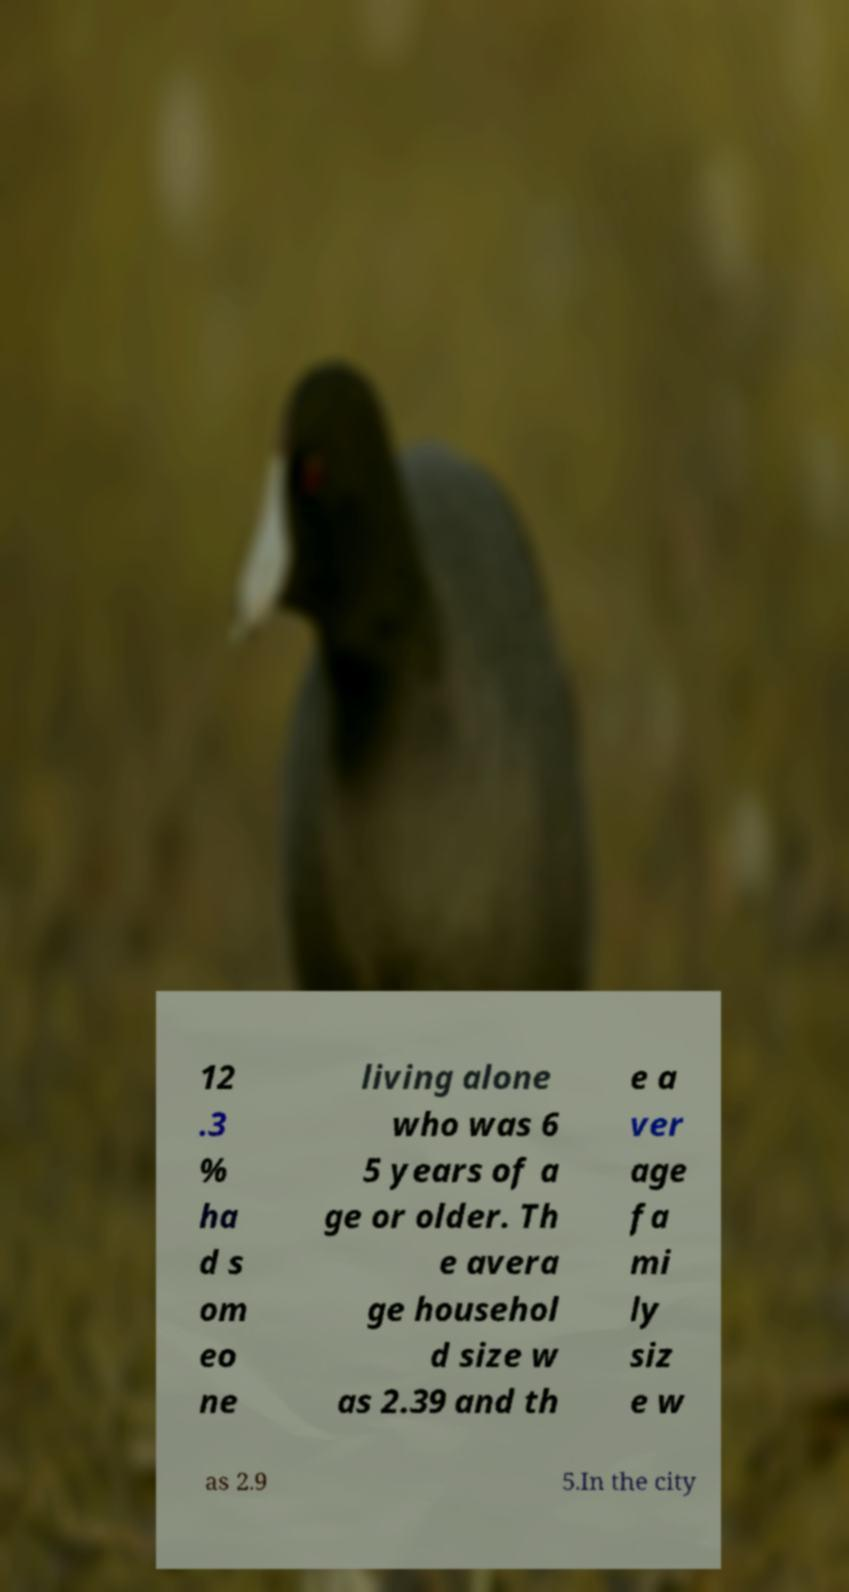Please read and relay the text visible in this image. What does it say? 12 .3 % ha d s om eo ne living alone who was 6 5 years of a ge or older. Th e avera ge househol d size w as 2.39 and th e a ver age fa mi ly siz e w as 2.9 5.In the city 